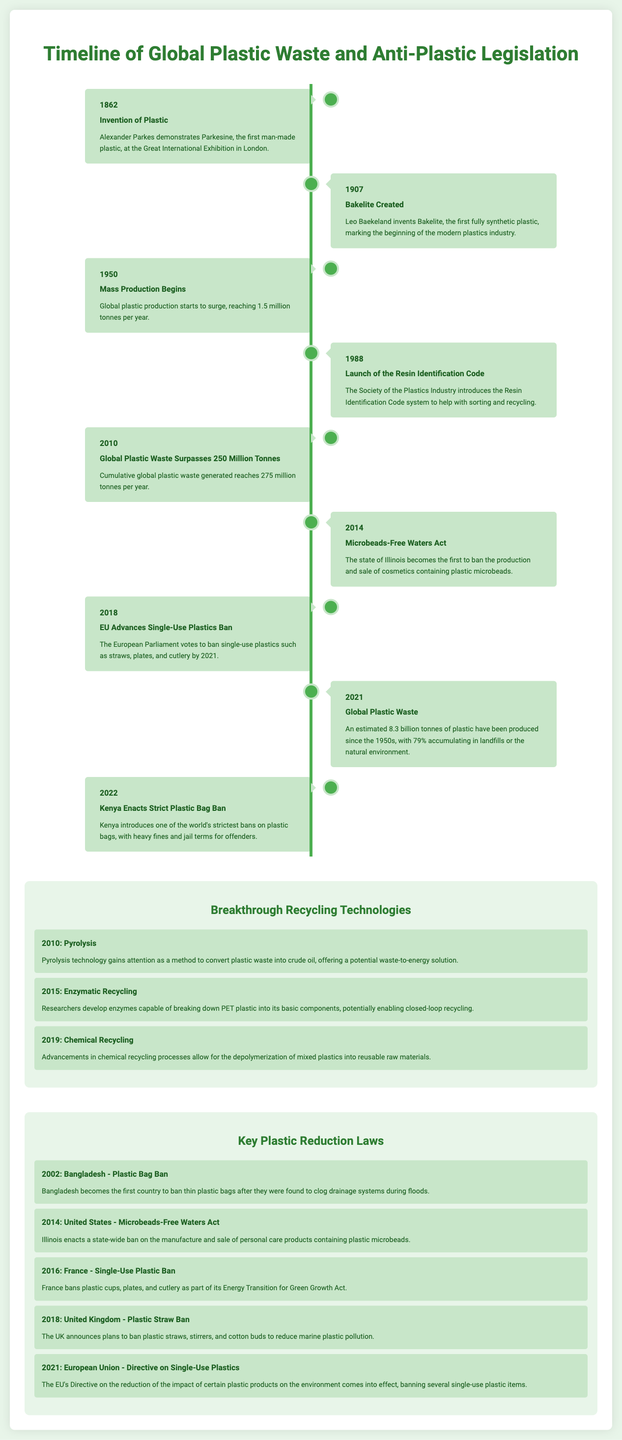what year was the invention of plastic? The invention of plastic is marked in the document by the year 1862.
Answer: 1862 what is the title of the legislation enacted in 2014 in Illinois? In 2014, the legislation is titled the Microbeads-Free Waters Act, which is mentioned in the document.
Answer: Microbeads-Free Waters Act how many tonnes of plastic waste were generated globally by 2010? The document states that by 2010, cumulative global plastic waste reached 275 million tonnes.
Answer: 275 million tonnes which country was the first to enact a plastic bag ban? Bangladesh is noted in the document as the first country to ban thin plastic bags in 2002.
Answer: Bangladesh what breakthrough recycling technology was introduced in 2019? The document mentions that advancements in chemical recycling processes occurred in 2019.
Answer: Chemical Recycling what is the main focus of the European Union's legislation enacted in 2021? The focus of the EU's legislation in 2021 is the reduction of single-use plastics as indicated in the document.
Answer: Single-Use Plastics which plastics were banned by the EU in 2018? The EU advanced a ban on single-use plastics such as straws, plates, and cutlery in 2018.
Answer: Straws, plates, and cutlery how many billion tonnes of plastic have been produced by 2021 since the 1950s? By 2021, the document states that an estimated 8.3 billion tonnes of plastic have been produced.
Answer: 8.3 billion tonnes 